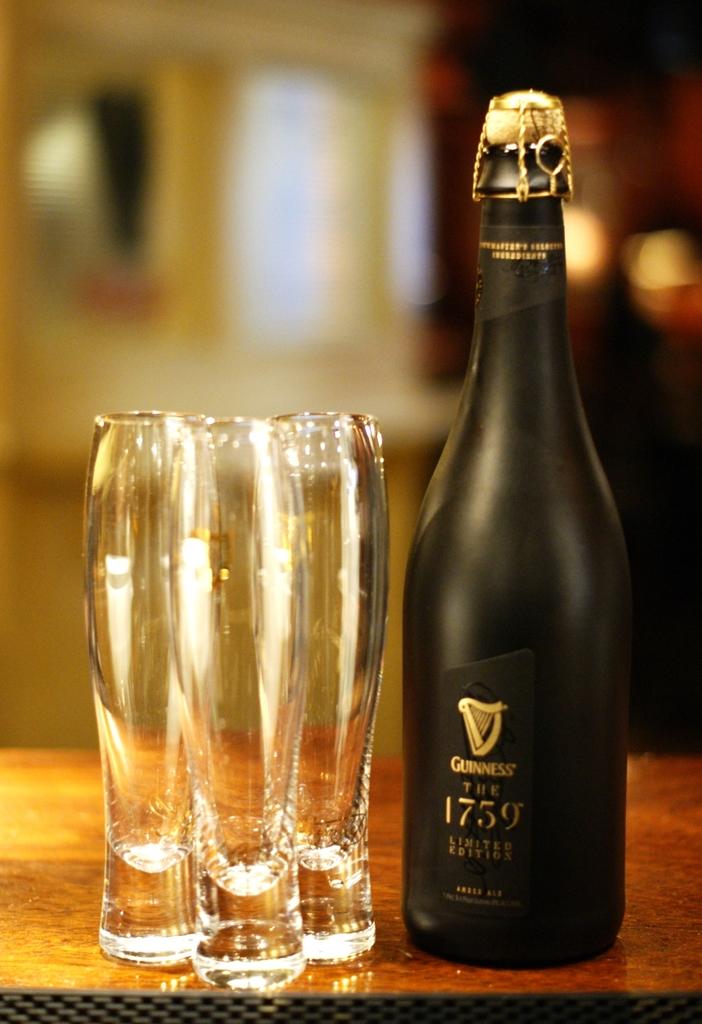What is inside of this bottle?
Provide a short and direct response. Guinness. 